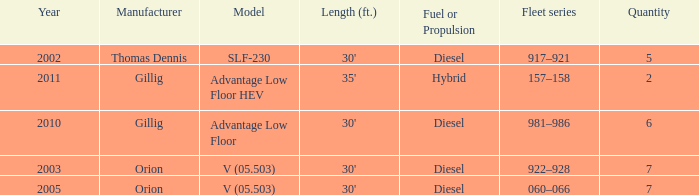Calculate the overall sum of slf-230 units manufactured before the year 2011. 5.0. 